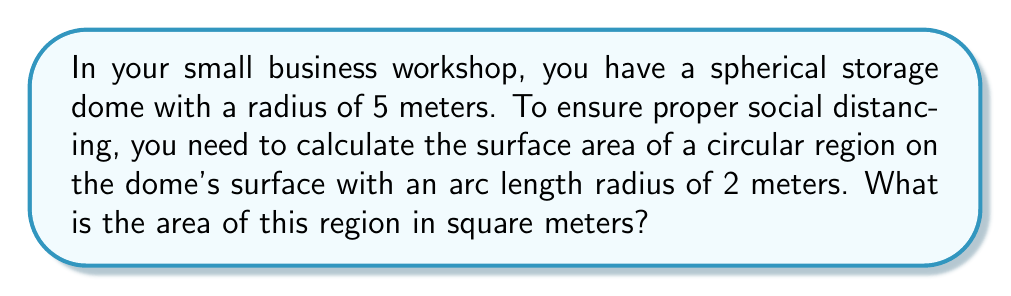Teach me how to tackle this problem. To solve this problem, we need to use concepts from non-Euclidean geometry, specifically spherical geometry. Let's approach this step-by-step:

1) The formula for the area of a spherical cap is:

   $$A = 2\pi R h$$

   where $R$ is the radius of the sphere and $h$ is the height of the cap.

2) We need to find $h$. We can do this using the formula for the arc length on a sphere:

   $$s = R\theta$$

   where $s$ is the arc length (2 meters in our case), $R$ is the radius of the sphere (5 meters), and $\theta$ is the central angle in radians.

3) Rearranging the arc length formula:

   $$\theta = \frac{s}{R} = \frac{2}{5} = 0.4 \text{ radians}$$

4) Now we can find $h$ using the formula:

   $$h = R(1 - \cos(\theta))$$

5) Plugging in our values:

   $$h = 5(1 - \cos(0.4)) \approx 0.1592 \text{ meters}$$

6) Now we can use the spherical cap area formula:

   $$A = 2\pi R h = 2\pi \cdot 5 \cdot 0.1592 \approx 5.0014 \text{ square meters}$$

Thus, the area of the circular region on the dome's surface is approximately 5.0014 square meters.
Answer: $5.0014 \text{ m}^2$ 